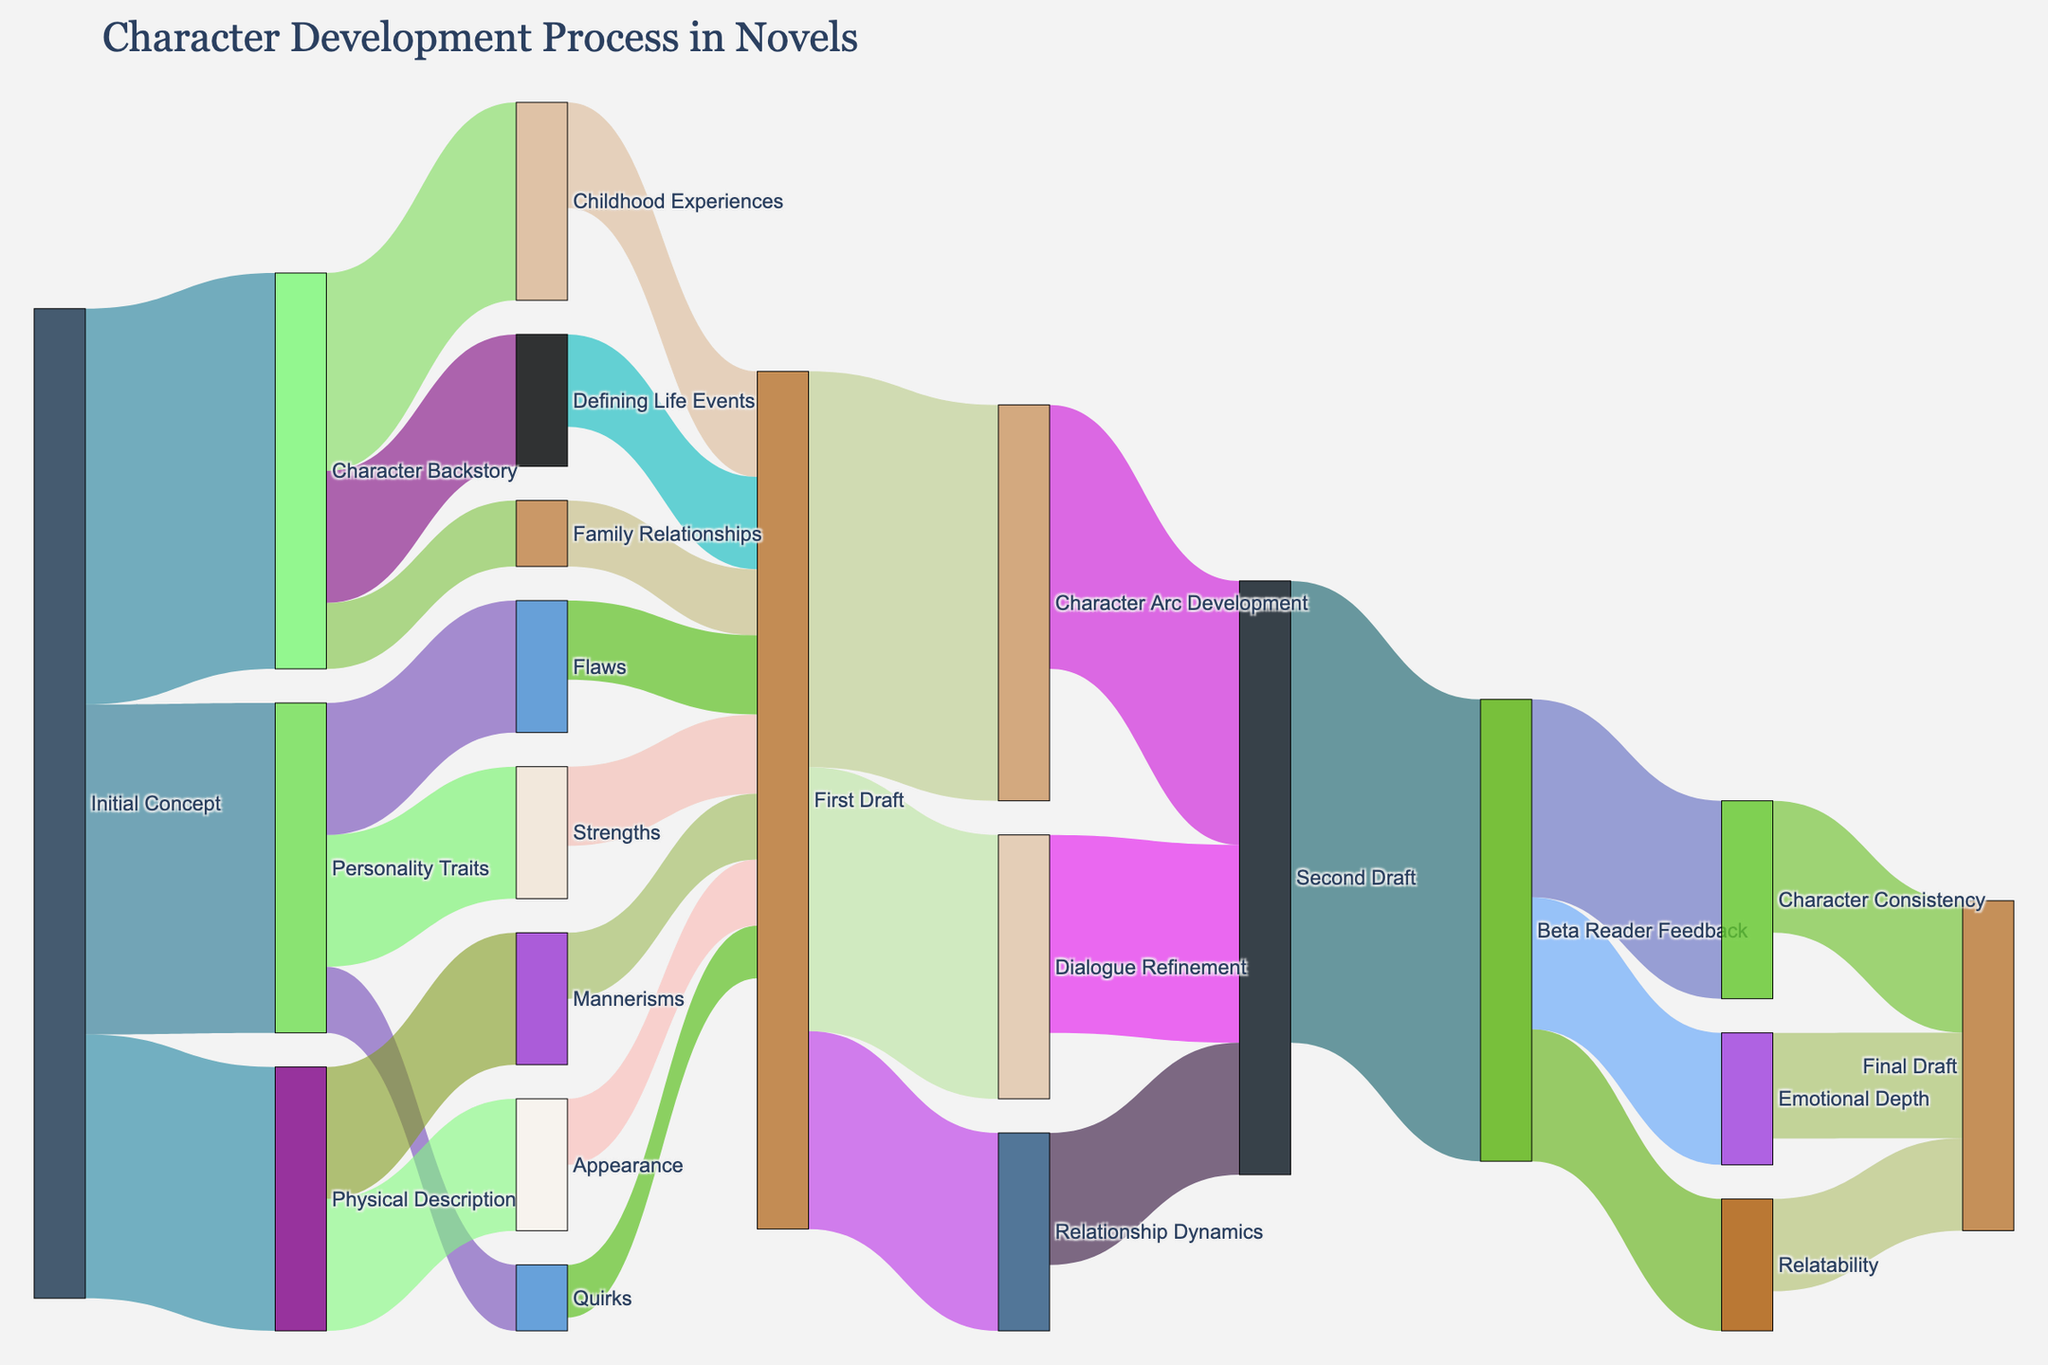What is the title of the Sankey Diagram? The title is usually displayed prominently and indicates the subject of the Sankey Diagram.
Answer: Character Development Process in Novels What initial concept has the highest value flowing to its subcategories? By looking at the width of the flows from each initial concept, we can identify that "Character Backstory" has the highest combined flow value.
Answer: Character Backstory How many subcategories does Personality Traits flow into, and what are they? Personality Traits has three subcategories, which are visible by the lines flowing from it. These subcategories are Strengths, Flaws, and Quirks.
Answer: 3, Strengths, Flaws, Quirks Among Strengths, Flaws, and Quirks, which has the largest flow value to the first draft? By comparing the widths of the lines flowing from Strengths, Flaws, and Quirks to the first draft, we can see that Strengths and Flaws are equal and larger than Quirks.
Answer: Strengths and Flaws Which subcategory has the smallest flow value to the first draft, and what is that value? By comparing all the flow values leading to the first draft, we identify the smallest value and its corresponding subcategory, which is "Quirks" with a value of 4.
Answer: Quirks, 4 How does the flow from the Second Draft to the Final Draft compare regarding Character Consistency and Emotional Depth? By looking at the widths of the lines from Second Draft to Character Consistency and Emotional Depth that eventually funnel into the Final Draft, Character Consistency has a greater value.
Answer: Character Consistency > Emotional Depth Summarize the top-level categories flowing into the Final Draft and their combined value. The top-level categories flowing into the Final Draft are Character Consistency, Emotional Depth, and Relatability. Summing these flow values gives 10 + 8 + 7 = 25.
Answer: Character Consistency, Emotional Depth, and Relatability; 25 What is the total value flowing from the First Draft? By summing the values of all outflows from the First Draft node: 30 (Character Arc Development) + 20 (Dialogue Refinement) + 15 (Relationship Dynamics) = 65.
Answer: 65 Which stage receives the highest combined flow value from beta reader feedback? By adding the values of the flows from Beta Reader Feedback to each category, we find the combined values of 15 (Character Consistency) + 10 (Emotional Depth) + 10 (Relatability) to determine which is higher. It's 15 for Character Consistency.
Answer: Character Consistency Describe the transition of "Physical Description" subcategories to the First Draft. Physical Description branches into Appearance and Mannerisms, and then both flow into the First Draft with values of 10 each.
Answer: Appearance and Mannerisms; 10 each 